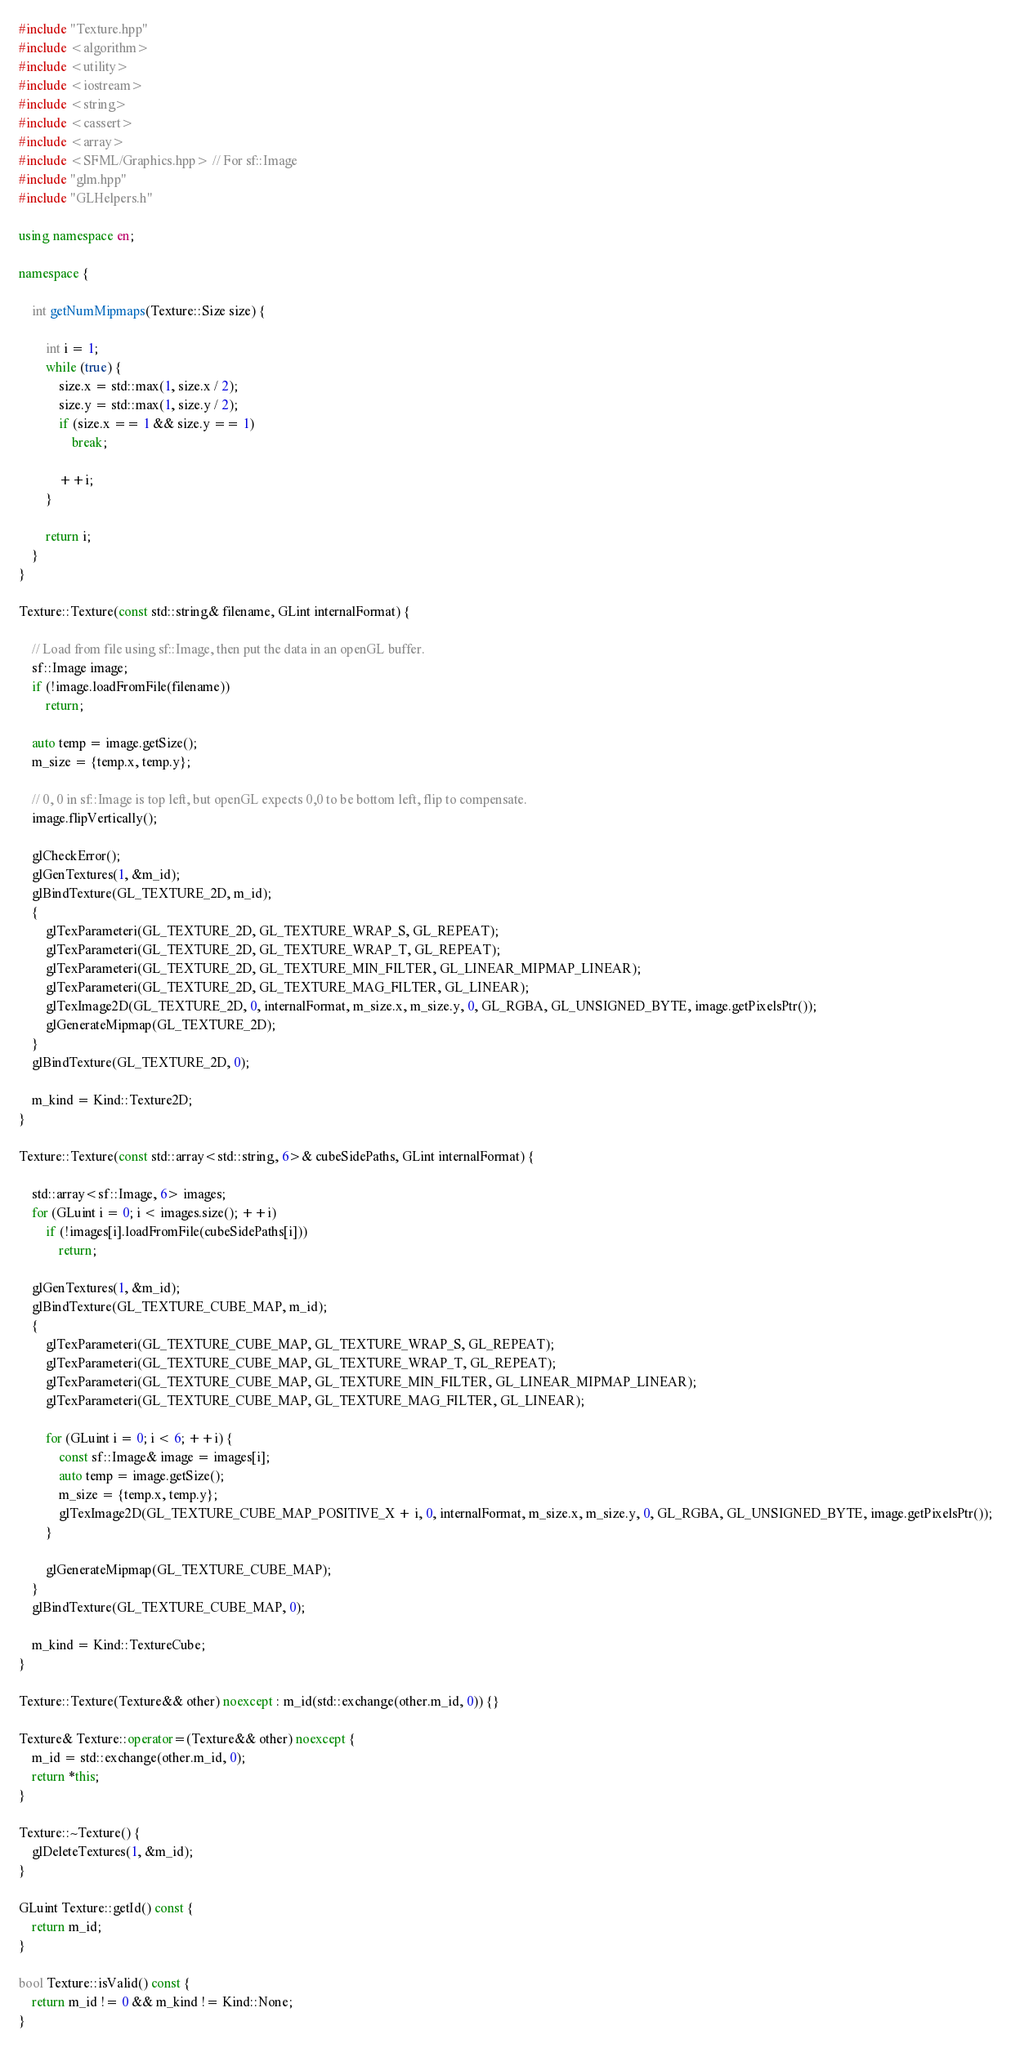<code> <loc_0><loc_0><loc_500><loc_500><_C++_>
#include "Texture.hpp"
#include <algorithm>
#include <utility>
#include <iostream>
#include <string>
#include <cassert>
#include <array>
#include <SFML/Graphics.hpp> // For sf::Image
#include "glm.hpp"
#include "GLHelpers.h"

using namespace en;

namespace {

    int getNumMipmaps(Texture::Size size) {

        int i = 1;
        while (true) {
            size.x = std::max(1, size.x / 2);
            size.y = std::max(1, size.y / 2);
            if (size.x == 1 && size.y == 1)
                break;

            ++i;
        }

        return i;
    }
}

Texture::Texture(const std::string& filename, GLint internalFormat) {

    // Load from file using sf::Image, then put the data in an openGL buffer.
    sf::Image image;
    if (!image.loadFromFile(filename))
        return;

    auto temp = image.getSize();
    m_size = {temp.x, temp.y};

    // 0, 0 in sf::Image is top left, but openGL expects 0,0 to be bottom left, flip to compensate.
    image.flipVertically();

    glCheckError();
    glGenTextures(1, &m_id);
    glBindTexture(GL_TEXTURE_2D, m_id);
    {
        glTexParameteri(GL_TEXTURE_2D, GL_TEXTURE_WRAP_S, GL_REPEAT);
        glTexParameteri(GL_TEXTURE_2D, GL_TEXTURE_WRAP_T, GL_REPEAT);
        glTexParameteri(GL_TEXTURE_2D, GL_TEXTURE_MIN_FILTER, GL_LINEAR_MIPMAP_LINEAR);
        glTexParameteri(GL_TEXTURE_2D, GL_TEXTURE_MAG_FILTER, GL_LINEAR);
        glTexImage2D(GL_TEXTURE_2D, 0, internalFormat, m_size.x, m_size.y, 0, GL_RGBA, GL_UNSIGNED_BYTE, image.getPixelsPtr());
        glGenerateMipmap(GL_TEXTURE_2D);
    }
    glBindTexture(GL_TEXTURE_2D, 0);

    m_kind = Kind::Texture2D;
}

Texture::Texture(const std::array<std::string, 6>& cubeSidePaths, GLint internalFormat) {

    std::array<sf::Image, 6> images;
    for (GLuint i = 0; i < images.size(); ++i)
        if (!images[i].loadFromFile(cubeSidePaths[i]))
            return;

    glGenTextures(1, &m_id);
    glBindTexture(GL_TEXTURE_CUBE_MAP, m_id);
    {
        glTexParameteri(GL_TEXTURE_CUBE_MAP, GL_TEXTURE_WRAP_S, GL_REPEAT);
        glTexParameteri(GL_TEXTURE_CUBE_MAP, GL_TEXTURE_WRAP_T, GL_REPEAT);
        glTexParameteri(GL_TEXTURE_CUBE_MAP, GL_TEXTURE_MIN_FILTER, GL_LINEAR_MIPMAP_LINEAR);
        glTexParameteri(GL_TEXTURE_CUBE_MAP, GL_TEXTURE_MAG_FILTER, GL_LINEAR);

        for (GLuint i = 0; i < 6; ++i) {
            const sf::Image& image = images[i];
            auto temp = image.getSize();
            m_size = {temp.x, temp.y};
            glTexImage2D(GL_TEXTURE_CUBE_MAP_POSITIVE_X + i, 0, internalFormat, m_size.x, m_size.y, 0, GL_RGBA, GL_UNSIGNED_BYTE, image.getPixelsPtr());
        }

        glGenerateMipmap(GL_TEXTURE_CUBE_MAP);
    }
    glBindTexture(GL_TEXTURE_CUBE_MAP, 0);

    m_kind = Kind::TextureCube;
}

Texture::Texture(Texture&& other) noexcept : m_id(std::exchange(other.m_id, 0)) {}

Texture& Texture::operator=(Texture&& other) noexcept {
    m_id = std::exchange(other.m_id, 0);
    return *this;
}

Texture::~Texture() {
	glDeleteTextures(1, &m_id);
}

GLuint Texture::getId() const {
	return m_id;
}

bool Texture::isValid() const {
    return m_id != 0 && m_kind != Kind::None;
}
</code> 